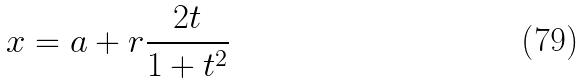Convert formula to latex. <formula><loc_0><loc_0><loc_500><loc_500>x = a + r \frac { 2 t } { 1 + t ^ { 2 } }</formula> 